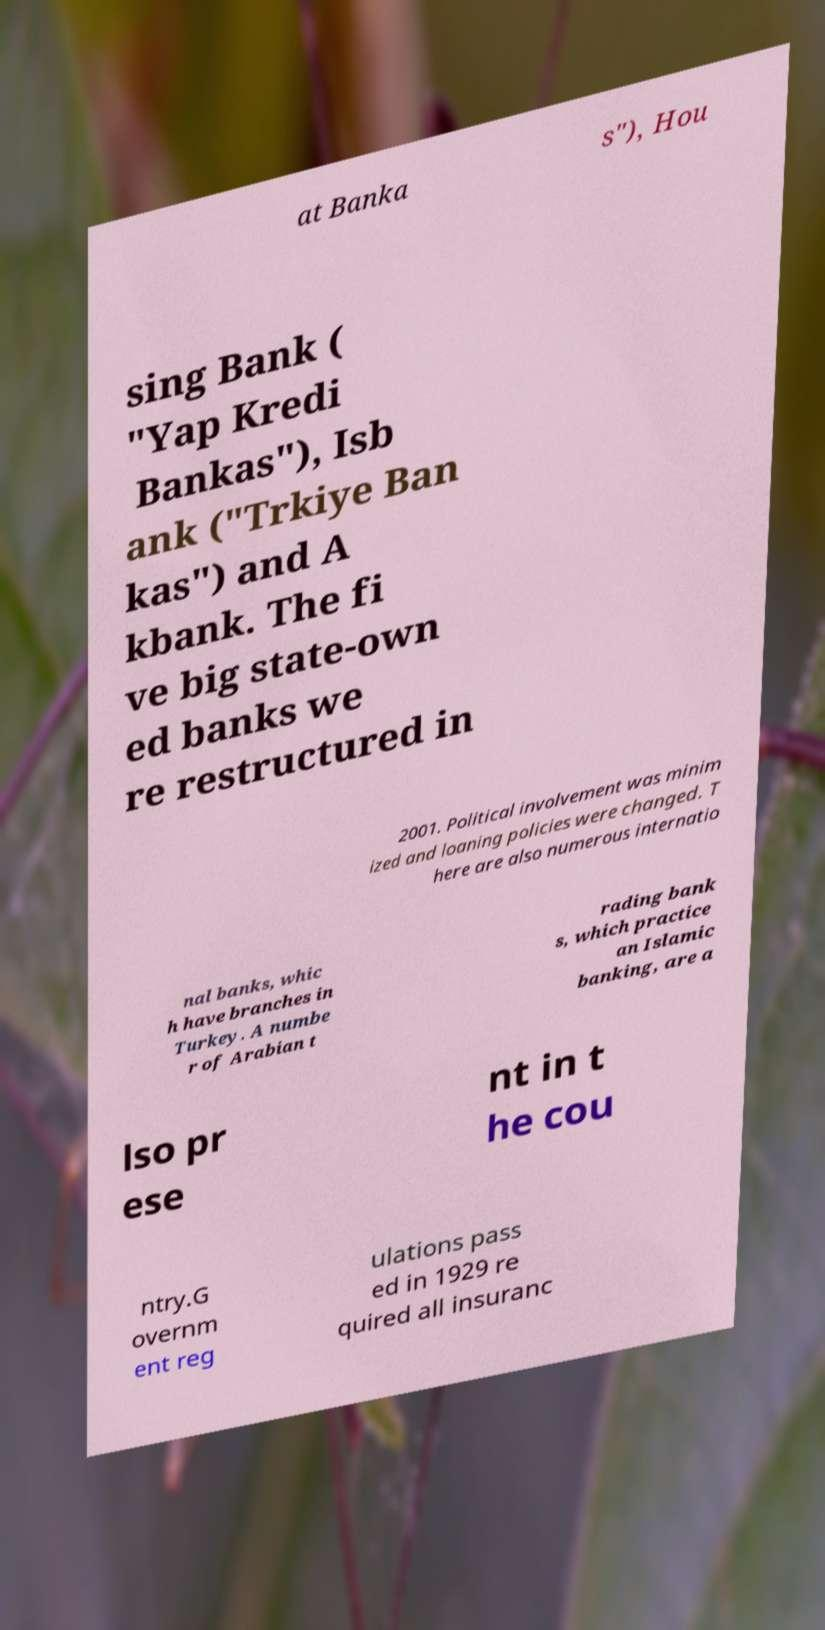Could you extract and type out the text from this image? at Banka s"), Hou sing Bank ( "Yap Kredi Bankas"), Isb ank ("Trkiye Ban kas") and A kbank. The fi ve big state-own ed banks we re restructured in 2001. Political involvement was minim ized and loaning policies were changed. T here are also numerous internatio nal banks, whic h have branches in Turkey. A numbe r of Arabian t rading bank s, which practice an Islamic banking, are a lso pr ese nt in t he cou ntry.G overnm ent reg ulations pass ed in 1929 re quired all insuranc 